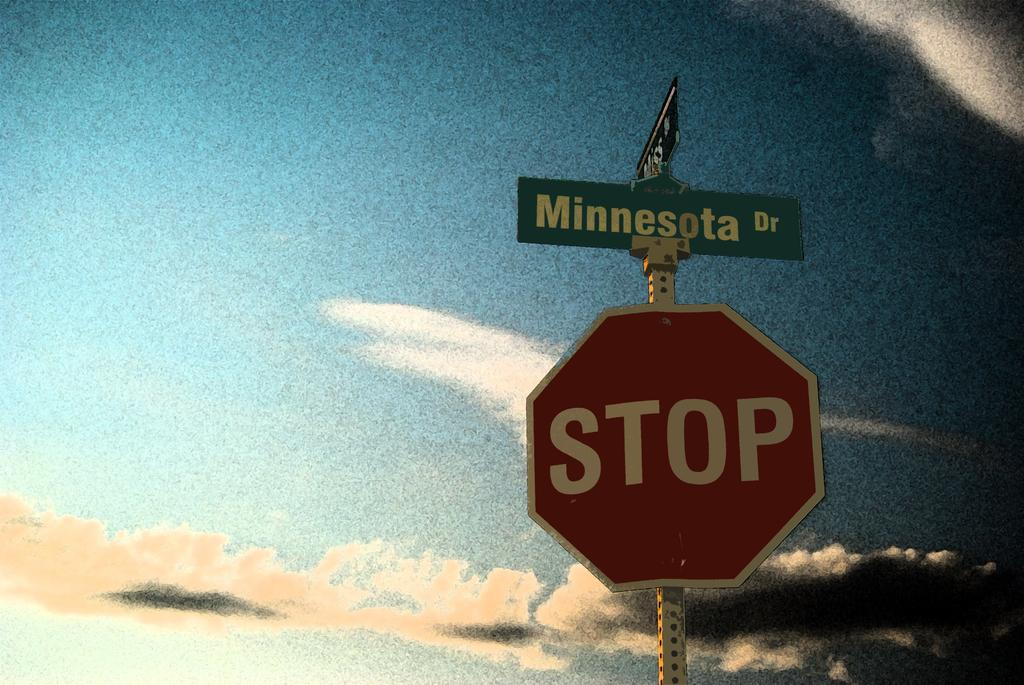<image>
Relay a brief, clear account of the picture shown. a street sign that says Minnesota Dr and a red STOP sign 